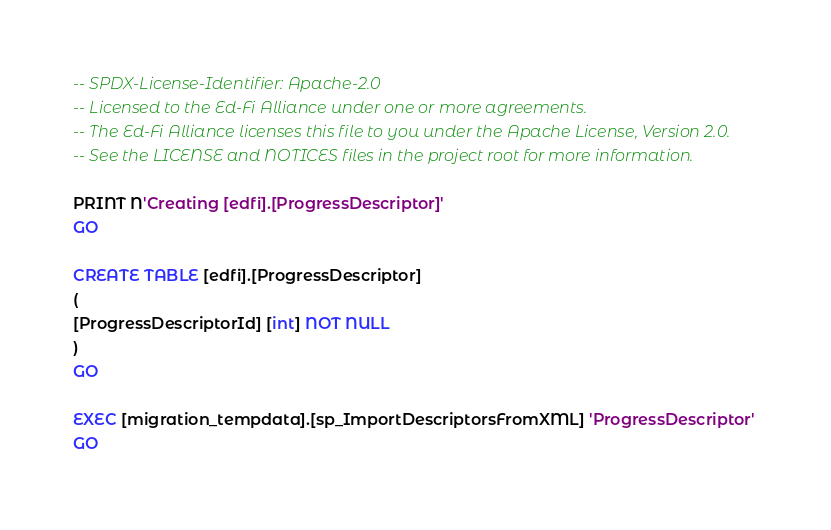Convert code to text. <code><loc_0><loc_0><loc_500><loc_500><_SQL_>-- SPDX-License-Identifier: Apache-2.0
-- Licensed to the Ed-Fi Alliance under one or more agreements.
-- The Ed-Fi Alliance licenses this file to you under the Apache License, Version 2.0.
-- See the LICENSE and NOTICES files in the project root for more information.

PRINT N'Creating [edfi].[ProgressDescriptor]'
GO

CREATE TABLE [edfi].[ProgressDescriptor]
(
[ProgressDescriptorId] [int] NOT NULL
)
GO

EXEC [migration_tempdata].[sp_ImportDescriptorsFromXML] 'ProgressDescriptor'
GO

</code> 